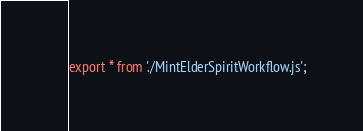Convert code to text. <code><loc_0><loc_0><loc_500><loc_500><_JavaScript_>export * from './MintElderSpiritWorkflow.js';
</code> 